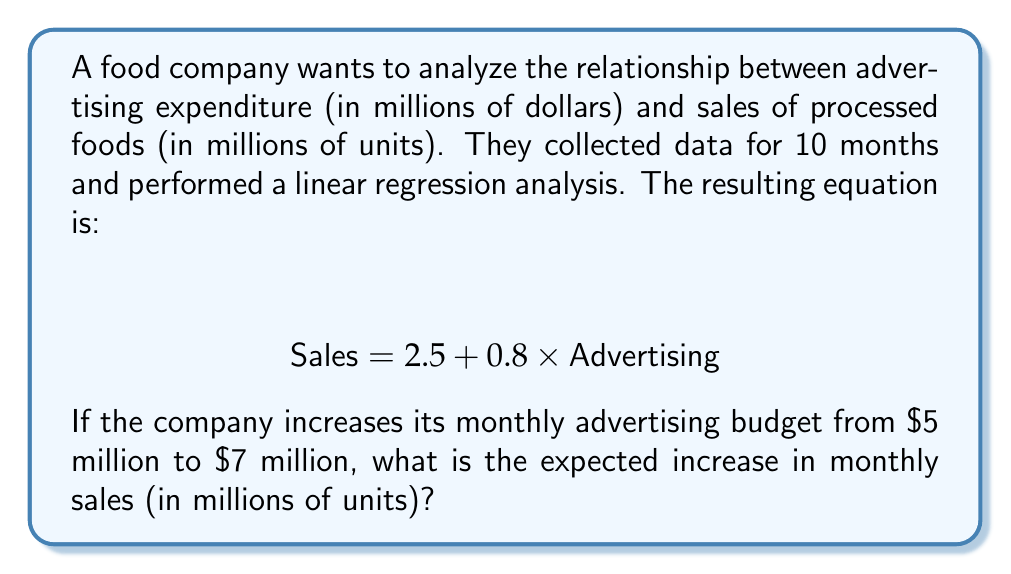Can you solve this math problem? To solve this problem, we'll follow these steps:

1) The linear regression equation is given as:
   $$ \text{Sales} = 2.5 + 0.8 \times \text{Advertising} $$

2) Calculate sales at $5 million advertising:
   $$ \text{Sales}_5 = 2.5 + 0.8 \times 5 = 2.5 + 4 = 6.5 \text{ million units} $$

3) Calculate sales at $7 million advertising:
   $$ \text{Sales}_7 = 2.5 + 0.8 \times 7 = 2.5 + 5.6 = 8.1 \text{ million units} $$

4) Calculate the difference in sales:
   $$ \Delta \text{Sales} = \text{Sales}_7 - \text{Sales}_5 = 8.1 - 6.5 = 1.6 \text{ million units} $$

Therefore, the expected increase in monthly sales is 1.6 million units.
Answer: 1.6 million units 